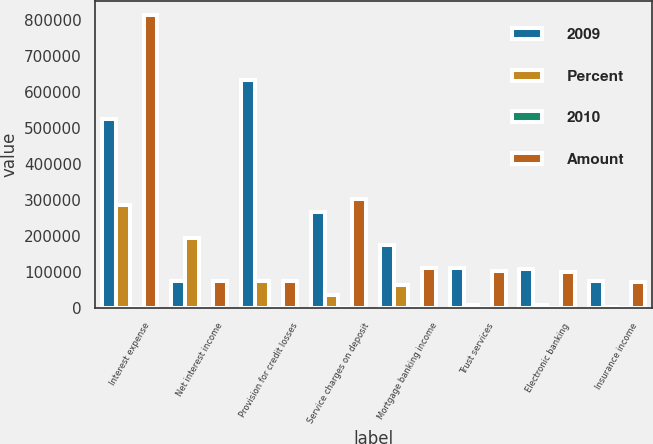Convert chart. <chart><loc_0><loc_0><loc_500><loc_500><stacked_bar_chart><ecel><fcel>Interest expense<fcel>Net interest income<fcel>Provision for credit losses<fcel>Service charges on deposit<fcel>Mortgage banking income<fcel>Trust services<fcel>Electronic banking<fcel>Insurance income<nl><fcel>2009<fcel>526587<fcel>74869.5<fcel>634547<fcel>267015<fcel>175782<fcel>112555<fcel>110234<fcel>76413<nl><fcel>Percent<fcel>287268<fcel>194518<fcel>74869.5<fcel>35784<fcel>63484<fcel>8916<fcel>10083<fcel>3087<nl><fcel>2010<fcel>35<fcel>14<fcel>69<fcel>12<fcel>57<fcel>9<fcel>10<fcel>4<nl><fcel>Amount<fcel>813855<fcel>74869.5<fcel>74869.5<fcel>302799<fcel>112298<fcel>103639<fcel>100151<fcel>73326<nl></chart> 